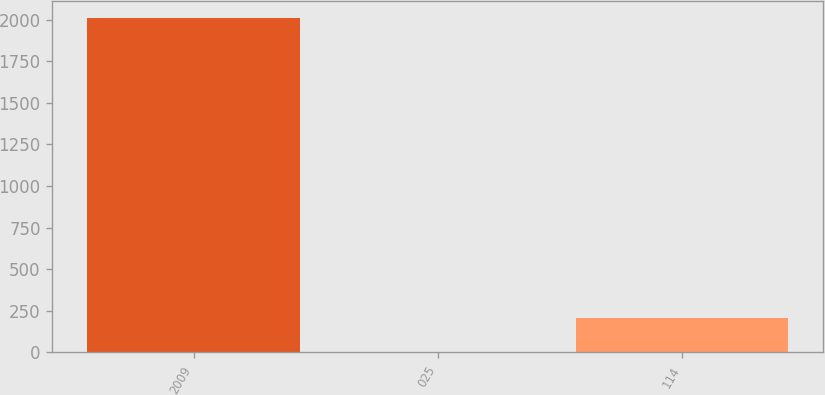Convert chart to OTSL. <chart><loc_0><loc_0><loc_500><loc_500><bar_chart><fcel>2009<fcel>025<fcel>114<nl><fcel>2009<fcel>3.97<fcel>204.47<nl></chart> 